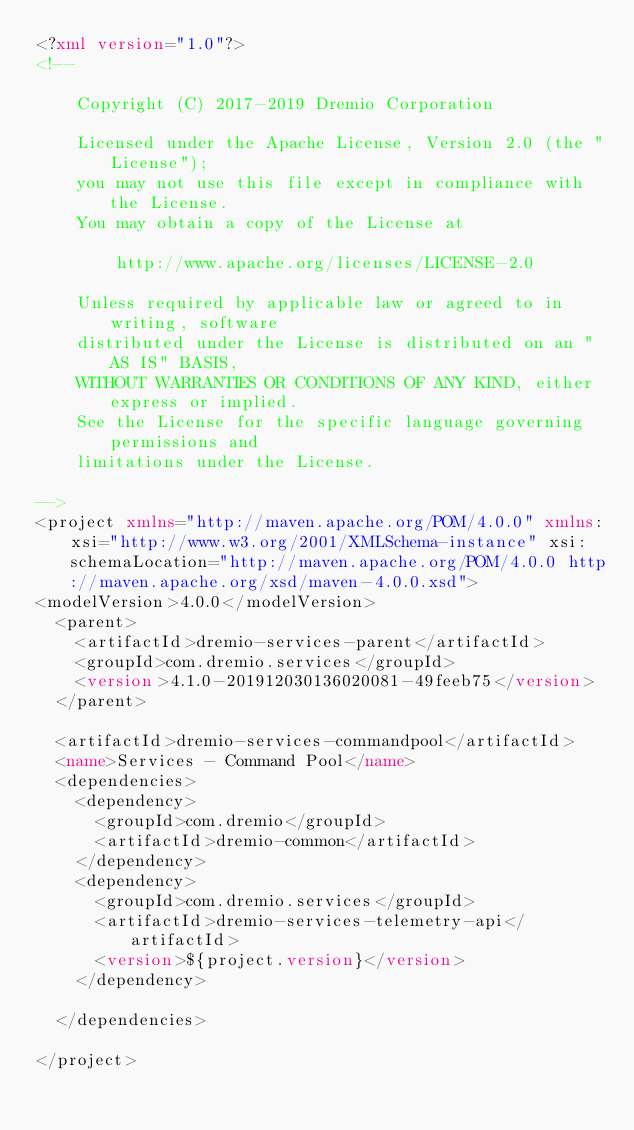<code> <loc_0><loc_0><loc_500><loc_500><_XML_><?xml version="1.0"?>
<!--

    Copyright (C) 2017-2019 Dremio Corporation

    Licensed under the Apache License, Version 2.0 (the "License");
    you may not use this file except in compliance with the License.
    You may obtain a copy of the License at

        http://www.apache.org/licenses/LICENSE-2.0

    Unless required by applicable law or agreed to in writing, software
    distributed under the License is distributed on an "AS IS" BASIS,
    WITHOUT WARRANTIES OR CONDITIONS OF ANY KIND, either express or implied.
    See the License for the specific language governing permissions and
    limitations under the License.

-->
<project xmlns="http://maven.apache.org/POM/4.0.0" xmlns:xsi="http://www.w3.org/2001/XMLSchema-instance" xsi:schemaLocation="http://maven.apache.org/POM/4.0.0 http://maven.apache.org/xsd/maven-4.0.0.xsd">
<modelVersion>4.0.0</modelVersion>
  <parent>
    <artifactId>dremio-services-parent</artifactId>
    <groupId>com.dremio.services</groupId>
    <version>4.1.0-201912030136020081-49feeb75</version>
  </parent>

  <artifactId>dremio-services-commandpool</artifactId>
  <name>Services - Command Pool</name>
  <dependencies>
    <dependency>
      <groupId>com.dremio</groupId>
      <artifactId>dremio-common</artifactId>
    </dependency>
    <dependency>
      <groupId>com.dremio.services</groupId>
      <artifactId>dremio-services-telemetry-api</artifactId>
      <version>${project.version}</version>
    </dependency>
    
  </dependencies>

</project>
</code> 